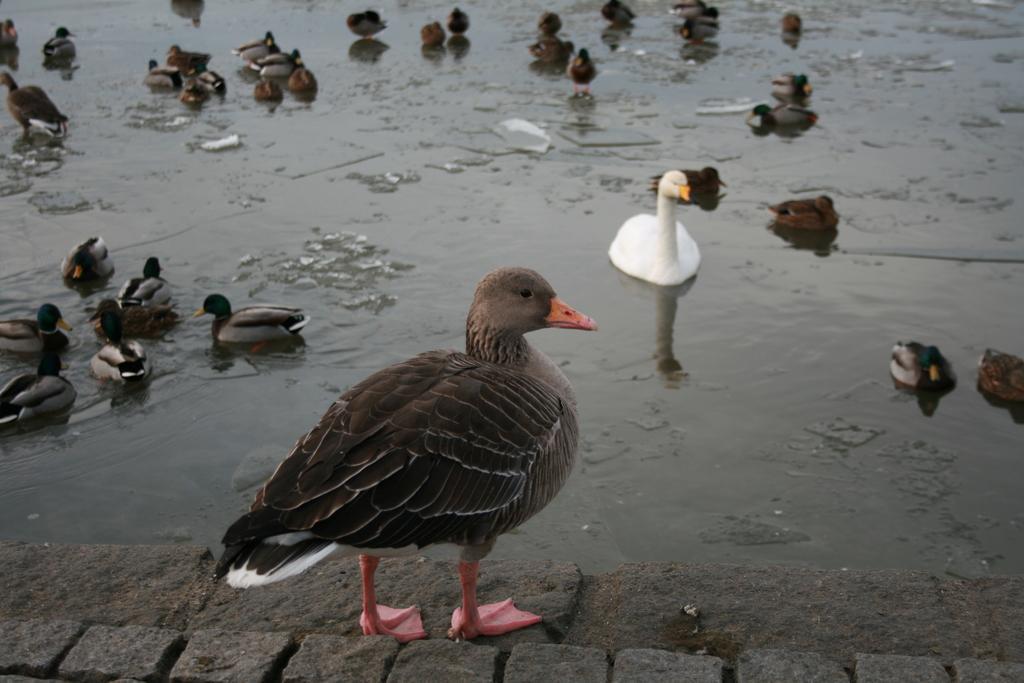Can you describe this image briefly? In this image we can see ducks and swan on the water. In the foreground there is a duck standing on the floor. 